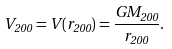Convert formula to latex. <formula><loc_0><loc_0><loc_500><loc_500>V _ { 2 0 0 } = V ( r _ { 2 0 0 } ) = \frac { G M _ { 2 0 0 } } { r _ { 2 0 0 } } .</formula> 